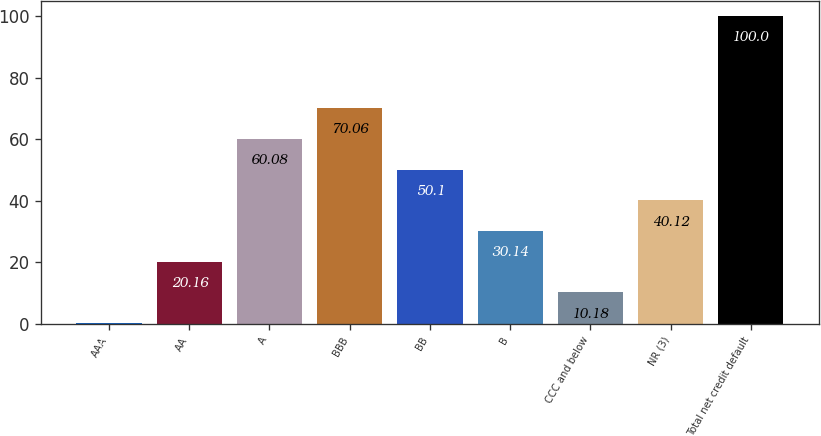Convert chart. <chart><loc_0><loc_0><loc_500><loc_500><bar_chart><fcel>AAA<fcel>AA<fcel>A<fcel>BBB<fcel>BB<fcel>B<fcel>CCC and below<fcel>NR (3)<fcel>Total net credit default<nl><fcel>0.2<fcel>20.16<fcel>60.08<fcel>70.06<fcel>50.1<fcel>30.14<fcel>10.18<fcel>40.12<fcel>100<nl></chart> 